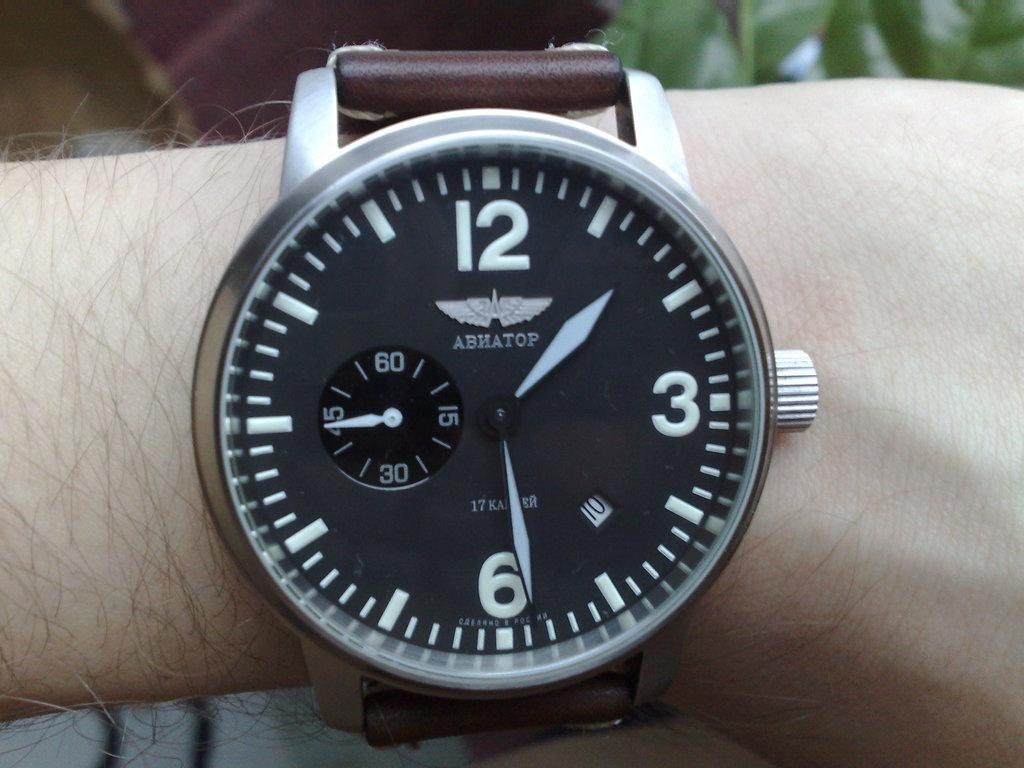<image>
Offer a succinct explanation of the picture presented. A black watch says "ABNATOP" on the face. 